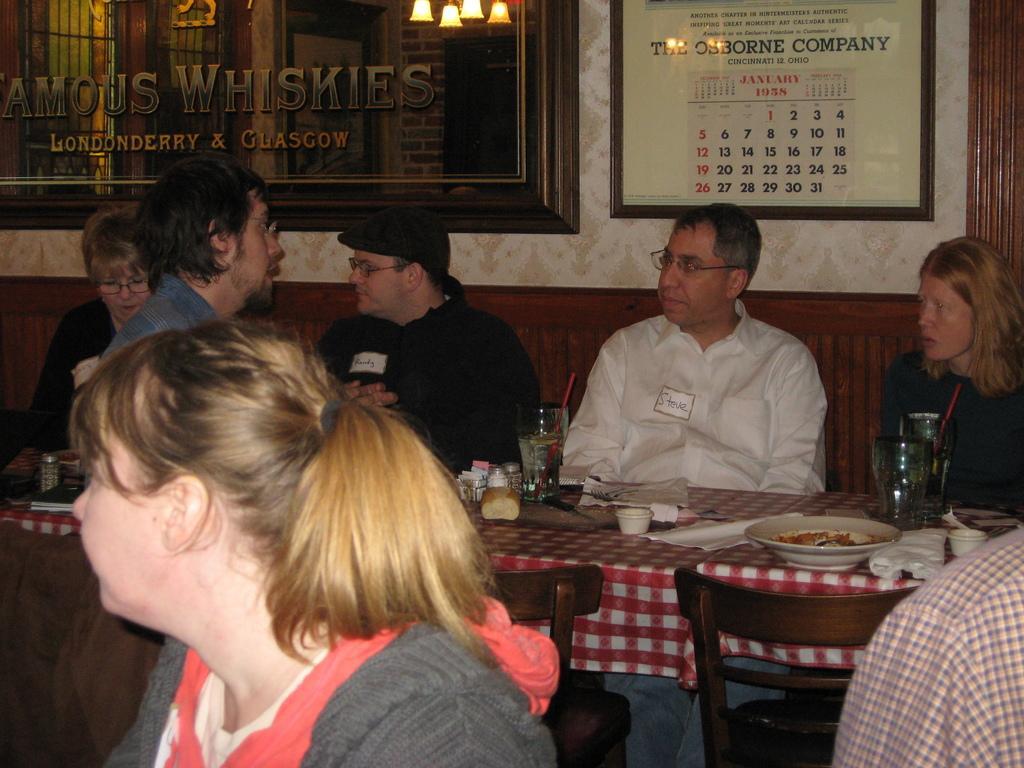In one or two sentences, can you explain what this image depicts? a person is sitting wearing a pink and a grey t shirt. behind them there is a table on which there is plate, glasses, napkin, bowl, food. people are seated around the table on the bench. the person at the right is wearing a black t shirt left to him a person is wearing white shirt. left to him a person is wearing a black shirt and a black cap. left to him a person is wearing black shirt. in front of them a person is standing wearing a blue shirt. behind them there is a wall on which there are 2 frames. on the left photo frame there is a calendar. 